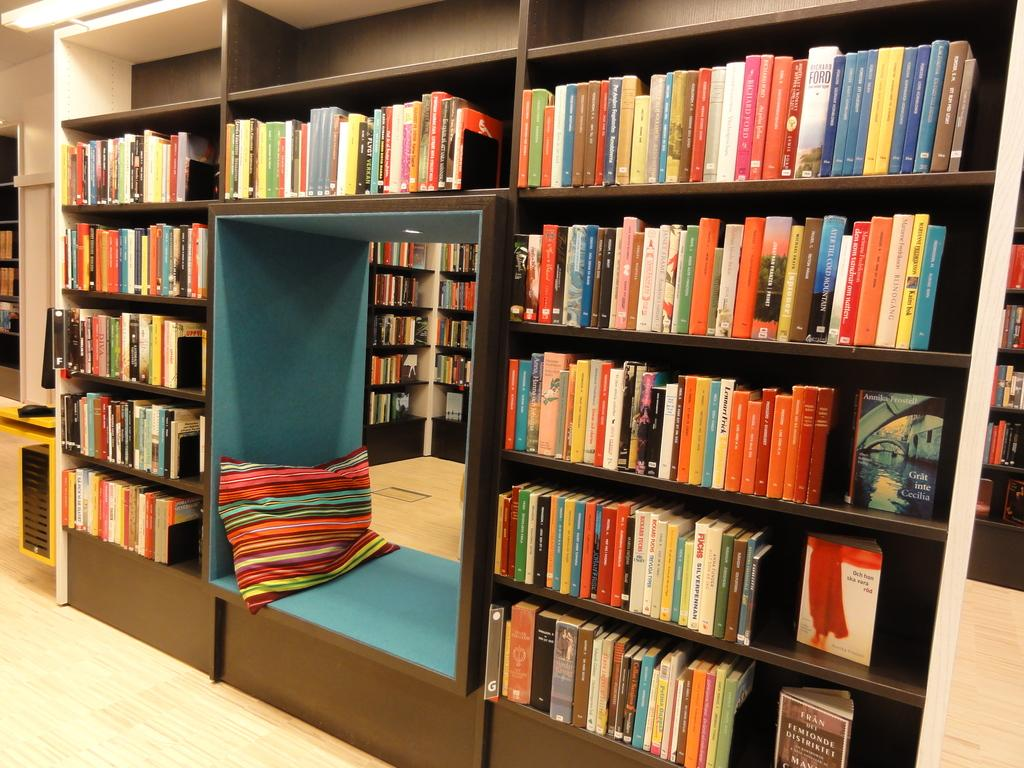What type of place is depicted in the image? The image appears to depict a library. What can be found in abundance in the library? There are many books in the racks. Is there anything unusual or out of place in the library? Yes, there is a pillow in one of the racks. What type of pickle can be seen in the image? There is no pickle present in the image. Can you tell me how the magic in the image is being used? There is no magic present in the image; it depicts a library with books and a pillow. 